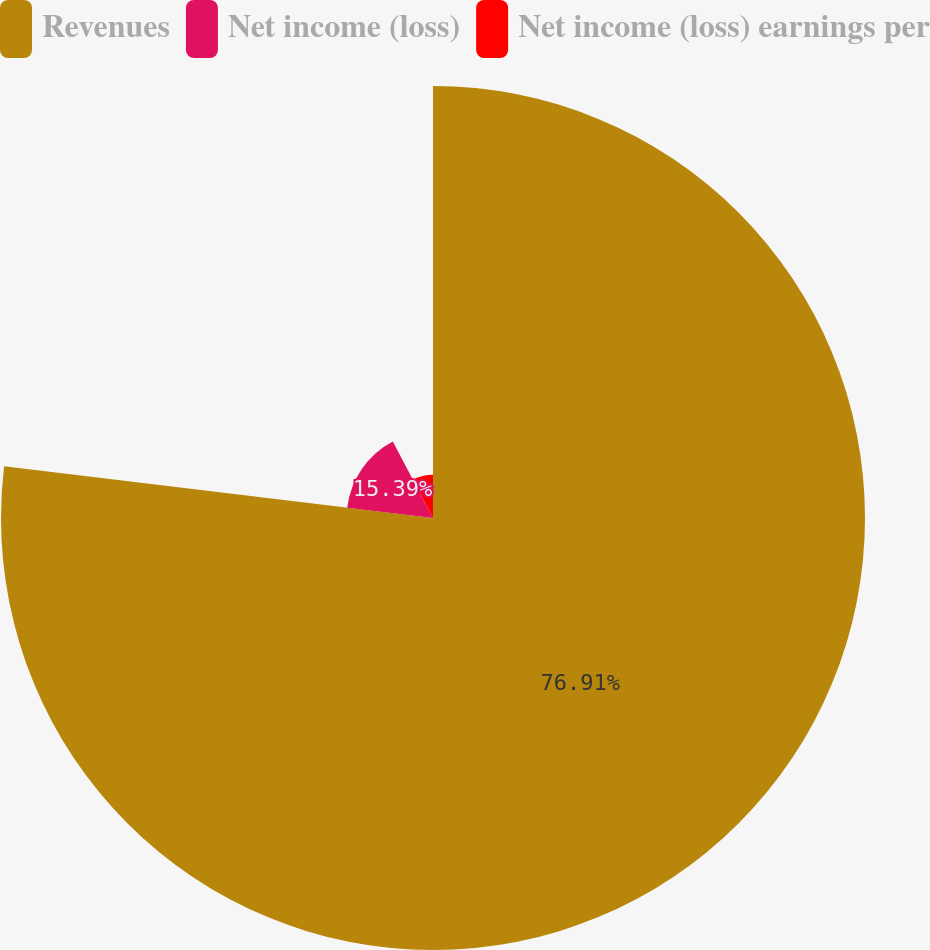Convert chart. <chart><loc_0><loc_0><loc_500><loc_500><pie_chart><fcel>Revenues<fcel>Net income (loss)<fcel>Net income (loss) earnings per<nl><fcel>76.92%<fcel>15.39%<fcel>7.7%<nl></chart> 